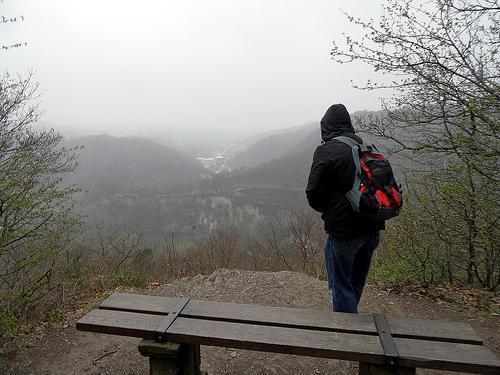How many people are there?
Give a very brief answer. 1. 